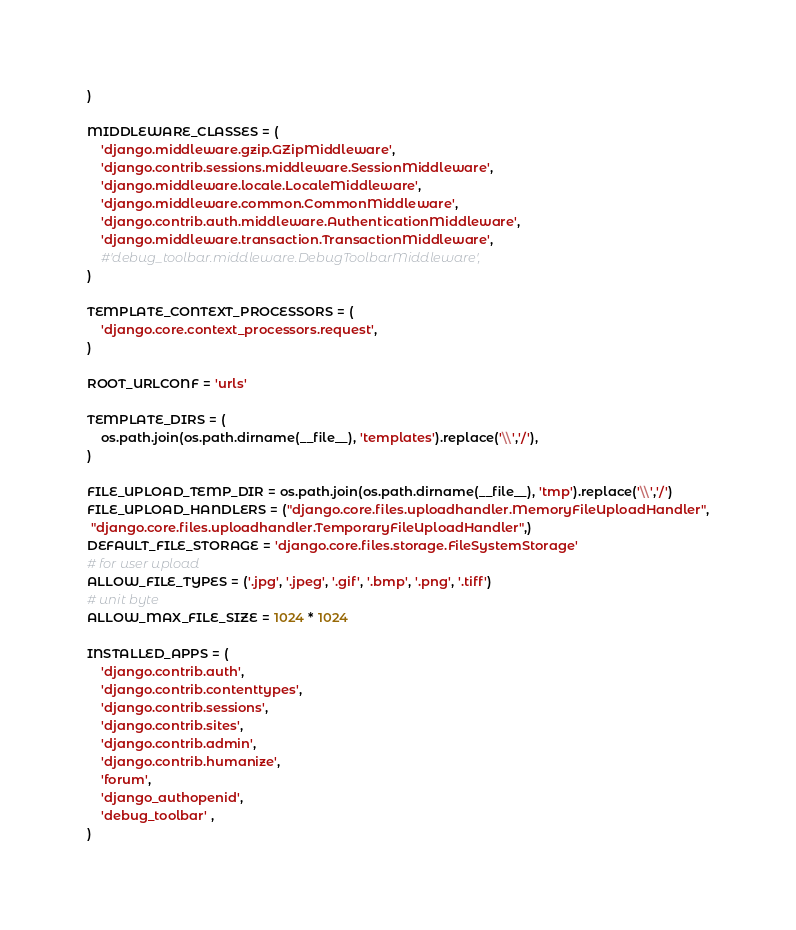<code> <loc_0><loc_0><loc_500><loc_500><_Python_>)

MIDDLEWARE_CLASSES = (
    'django.middleware.gzip.GZipMiddleware',
    'django.contrib.sessions.middleware.SessionMiddleware',
    'django.middleware.locale.LocaleMiddleware',
    'django.middleware.common.CommonMiddleware',
    'django.contrib.auth.middleware.AuthenticationMiddleware',
    'django.middleware.transaction.TransactionMiddleware',
    #'debug_toolbar.middleware.DebugToolbarMiddleware',
)

TEMPLATE_CONTEXT_PROCESSORS = (
    'django.core.context_processors.request',
)

ROOT_URLCONF = 'urls'

TEMPLATE_DIRS = (
    os.path.join(os.path.dirname(__file__), 'templates').replace('\\','/'),
)

FILE_UPLOAD_TEMP_DIR = os.path.join(os.path.dirname(__file__), 'tmp').replace('\\','/')
FILE_UPLOAD_HANDLERS = ("django.core.files.uploadhandler.MemoryFileUploadHandler",
 "django.core.files.uploadhandler.TemporaryFileUploadHandler",)
DEFAULT_FILE_STORAGE = 'django.core.files.storage.FileSystemStorage'
# for user upload
ALLOW_FILE_TYPES = ('.jpg', '.jpeg', '.gif', '.bmp', '.png', '.tiff')
# unit byte
ALLOW_MAX_FILE_SIZE = 1024 * 1024

INSTALLED_APPS = (
    'django.contrib.auth',
    'django.contrib.contenttypes',
    'django.contrib.sessions',
    'django.contrib.sites',
    'django.contrib.admin',
    'django.contrib.humanize',
    'forum',
    'django_authopenid',
    'debug_toolbar' ,
)</code> 